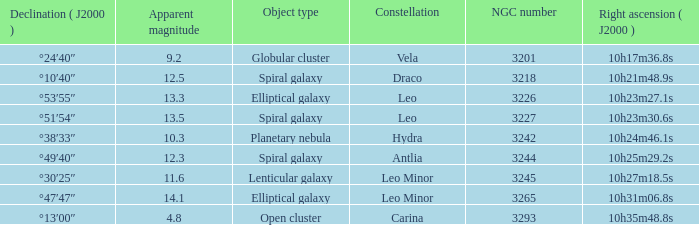What is the sum of NGC numbers for Constellation vela? 3201.0. 